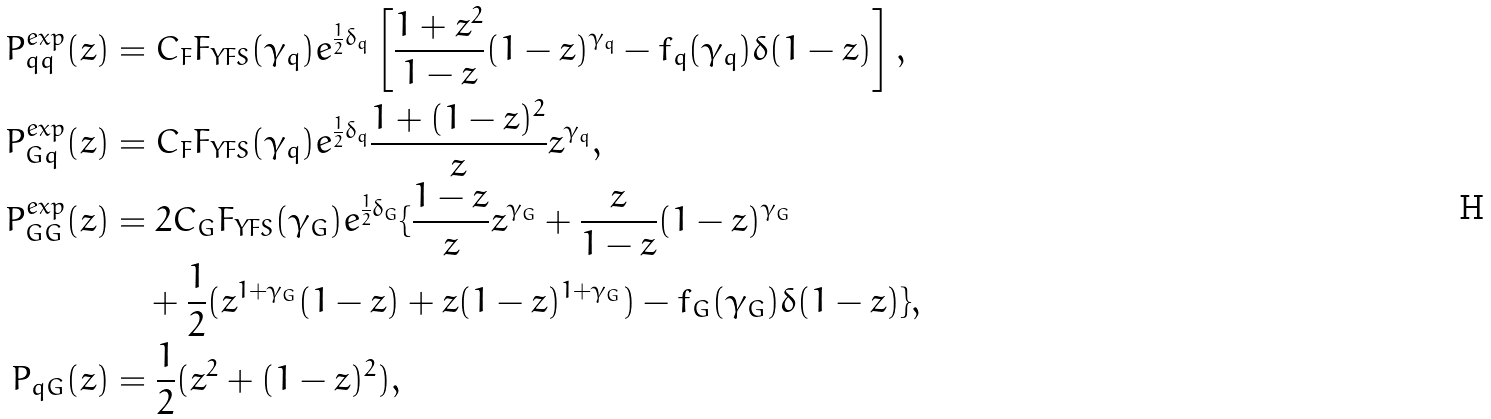<formula> <loc_0><loc_0><loc_500><loc_500>P _ { q q } ^ { e x p } ( z ) & = C _ { F } F _ { Y F S } ( \gamma _ { q } ) e ^ { \frac { 1 } { 2 } \delta _ { q } } \left [ \frac { 1 + z ^ { 2 } } { 1 - z } ( 1 - z ) ^ { \gamma _ { q } } - f _ { q } ( \gamma _ { q } ) \delta ( 1 - z ) \right ] , \\ P _ { G q } ^ { e x p } ( z ) & = C _ { F } F _ { Y F S } ( \gamma _ { q } ) e ^ { \frac { 1 } { 2 } \delta _ { q } } \frac { 1 + ( 1 - z ) ^ { 2 } } { z } z ^ { \gamma _ { q } } , \\ P _ { G G } ^ { e x p } ( z ) & = 2 C _ { G } F _ { Y F S } ( \gamma _ { G } ) e ^ { \frac { 1 } { 2 } \delta _ { G } } \{ \frac { 1 - z } { z } z ^ { \gamma _ { G } } + \frac { z } { 1 - z } ( 1 - z ) ^ { \gamma _ { G } } \\ & \quad + \frac { 1 } { 2 } ( z ^ { 1 + \gamma _ { G } } ( 1 - z ) + z ( 1 - z ) ^ { 1 + \gamma _ { G } } ) - f _ { G } ( \gamma _ { G } ) \delta ( 1 - z ) \} , \\ P _ { q G } ( z ) & = \frac { 1 } { 2 } ( z ^ { 2 } + ( 1 - z ) ^ { 2 } ) ,</formula> 